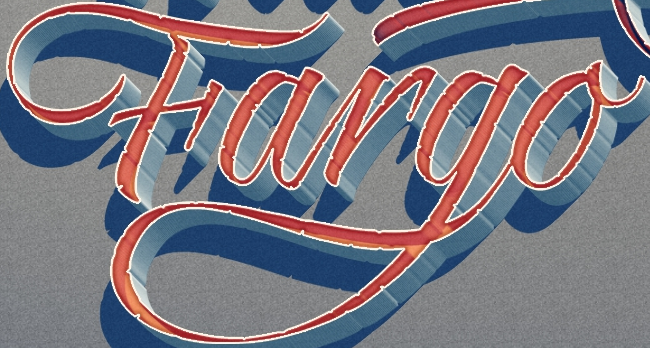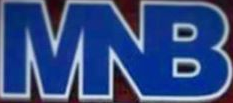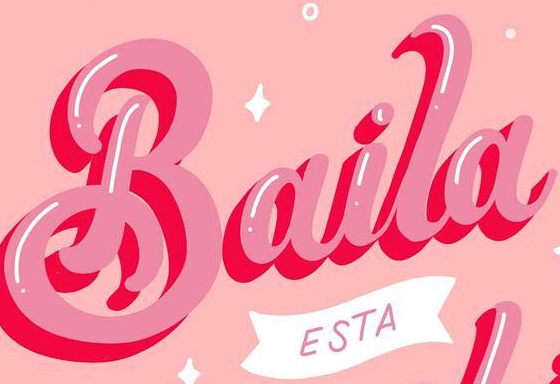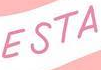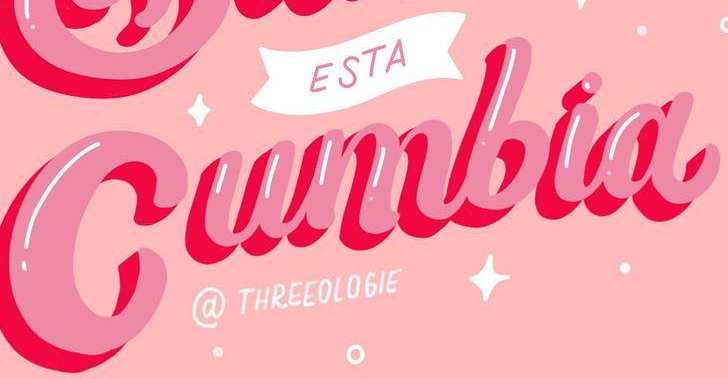Read the text from these images in sequence, separated by a semicolon. Fargo; MNB; Baila; ESTA; Cumbia 